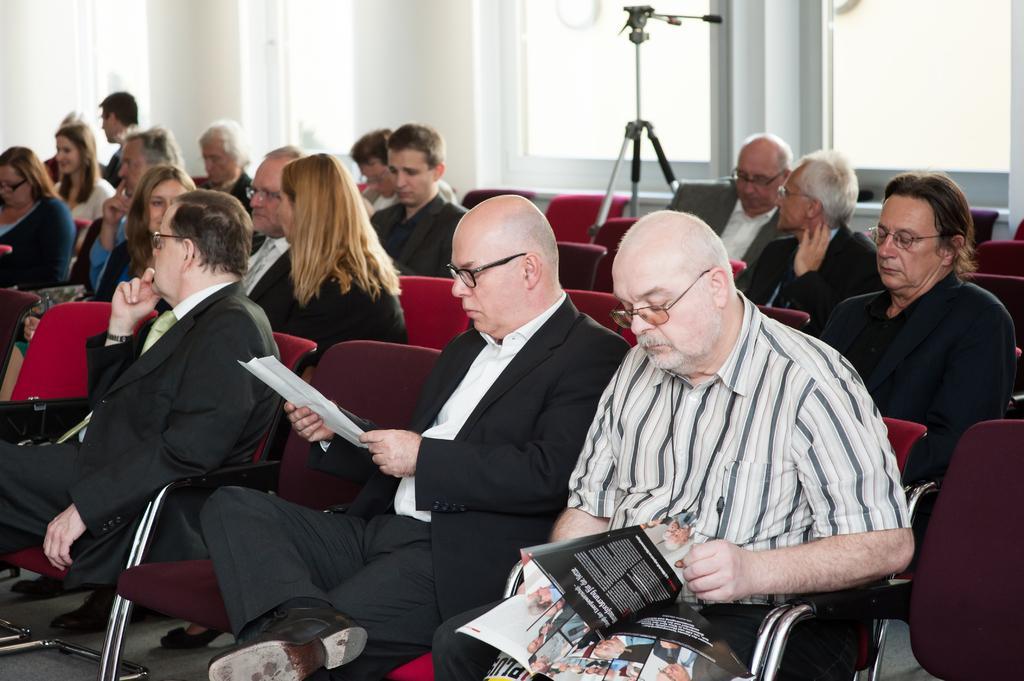How would you summarize this image in a sentence or two? The picture is taken in a closed room where many people are sitting on the chairs. In the front row two men are holding papers and books in their hands and behind them there is a one big door and one stand in the middle of the room is present. 